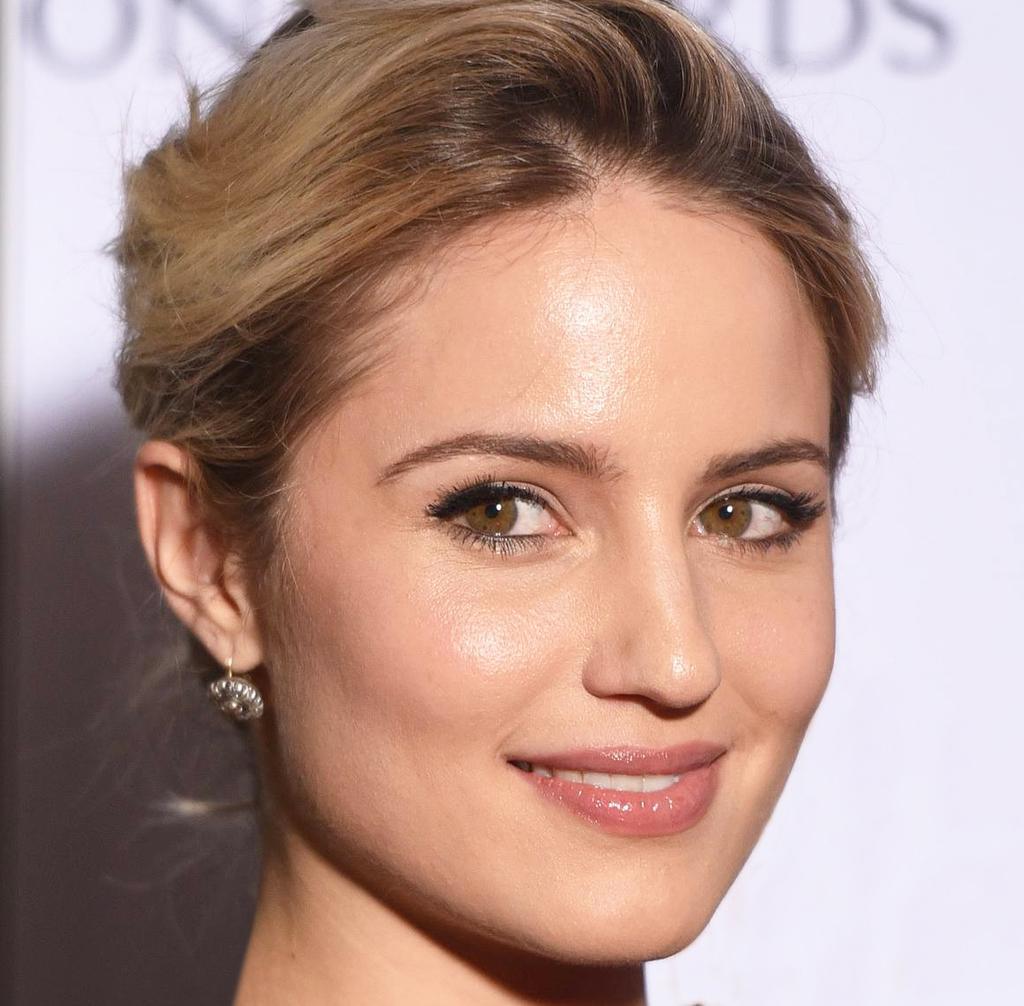Describe this image in one or two sentences. In this image we can see persons face and white background with text. 